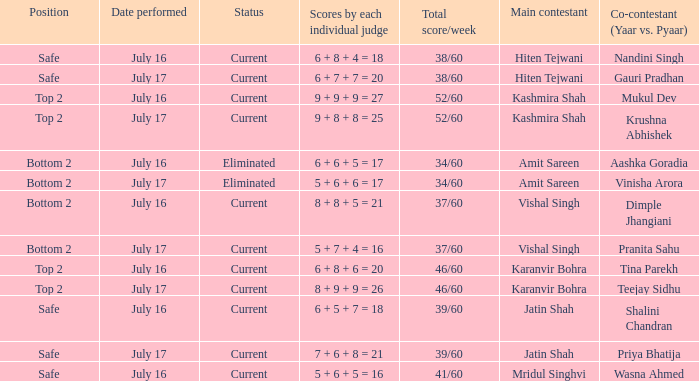What position did the team with the total score of 41/60 get? Safe. 